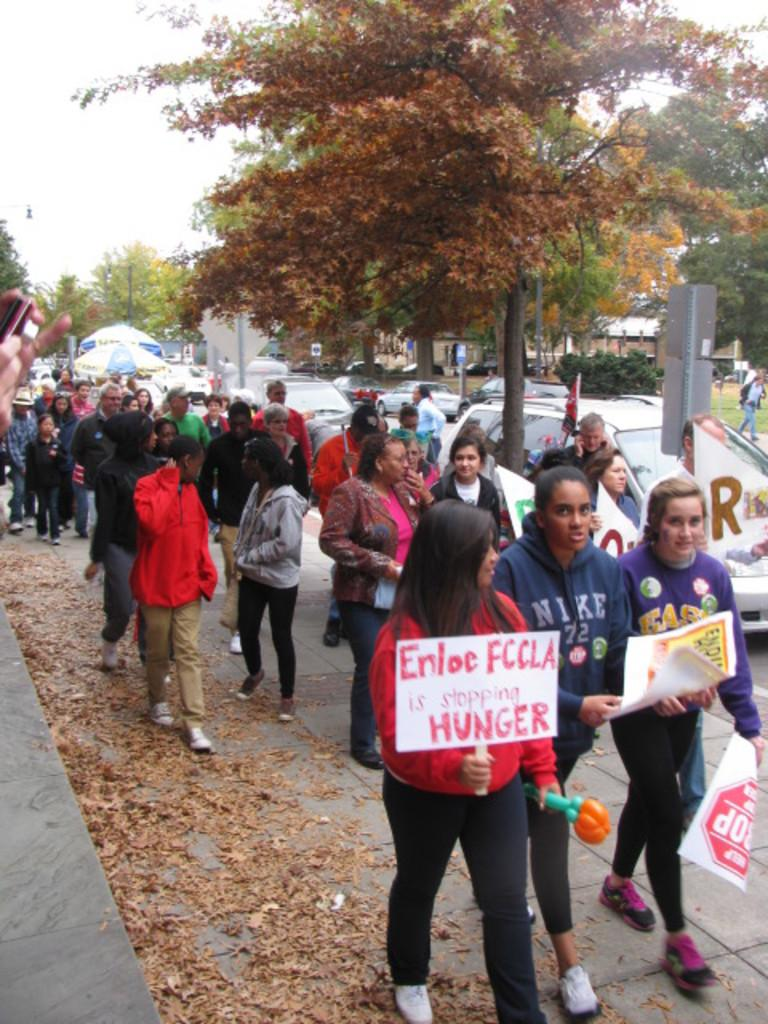Who or what can be seen in the image? There are people in the image. What are some of the people holding? Some of the people are holding placards. What else can be seen on the road in the image? There are cars on the road in the image. What type of vegetation is present in the image? There are trees in the image. What is visible in the background of the image? The sky is visible in the background of the image. Can you tell me how many experts are present in the image? There is no mention of experts in the image; it features people holding placards, cars on the road, trees, and a visible sky. What color is the tongue of the person in the image? There is no person's tongue visible in the image. 